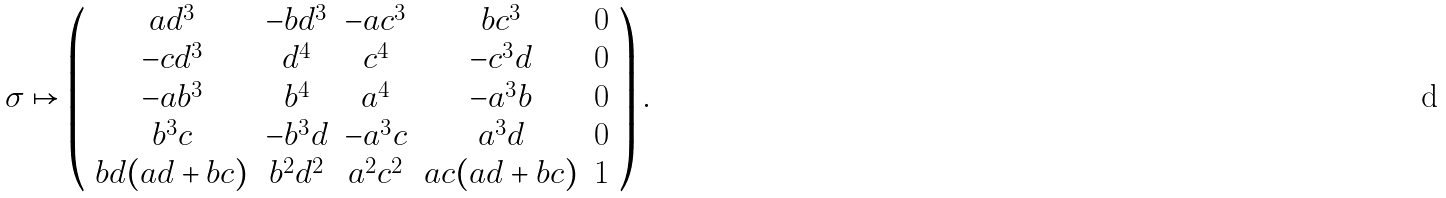<formula> <loc_0><loc_0><loc_500><loc_500>\sigma \mapsto \left ( \begin{array} { c c c c c } a d ^ { 3 } & - b d ^ { 3 } & - a c ^ { 3 } & b c ^ { 3 } & 0 \\ - c d ^ { 3 } & d ^ { 4 } & c ^ { 4 } & - c ^ { 3 } d & 0 \\ - a b ^ { 3 } & b ^ { 4 } & a ^ { 4 } & - a ^ { 3 } b & 0 \\ b ^ { 3 } c & - b ^ { 3 } d & - a ^ { 3 } c & a ^ { 3 } d & 0 \\ b d ( a d + b c ) & b ^ { 2 } d ^ { 2 } & a ^ { 2 } c ^ { 2 } & a c ( a d + b c ) & 1 \end{array} \right ) .</formula> 